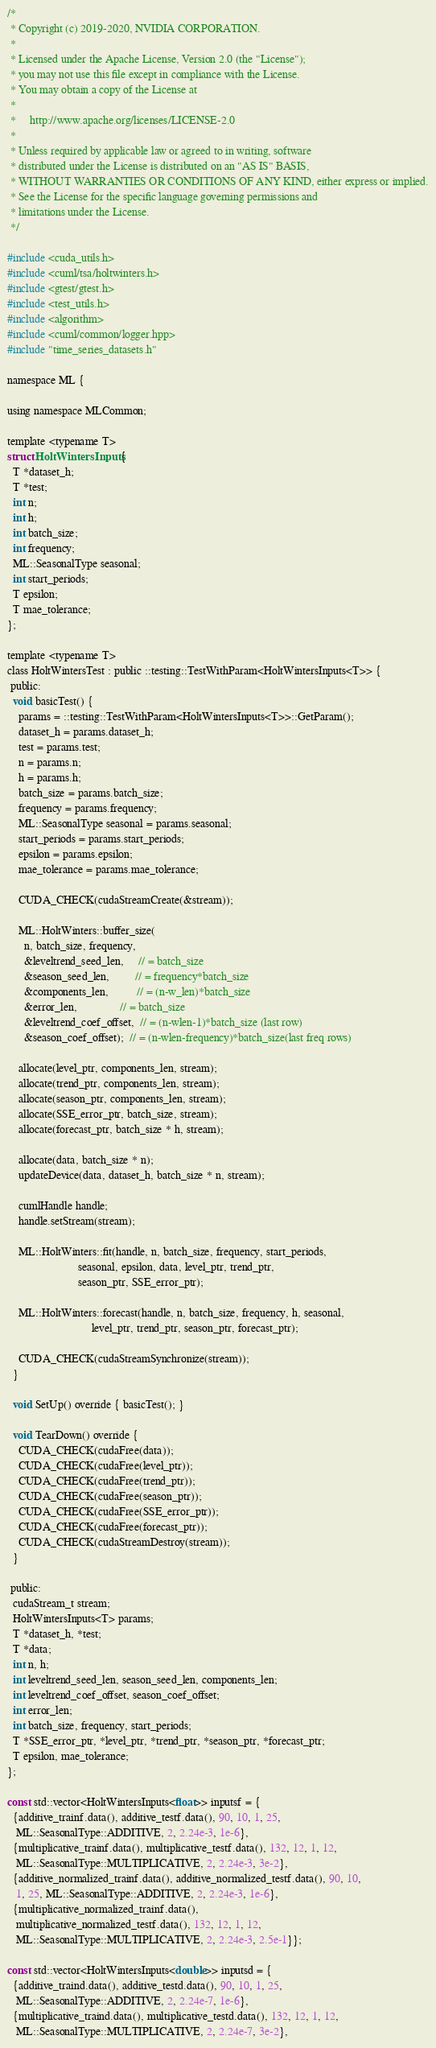<code> <loc_0><loc_0><loc_500><loc_500><_Cuda_>/*
 * Copyright (c) 2019-2020, NVIDIA CORPORATION.
 *
 * Licensed under the Apache License, Version 2.0 (the "License");
 * you may not use this file except in compliance with the License.
 * You may obtain a copy of the License at
 *
 *     http://www.apache.org/licenses/LICENSE-2.0
 *
 * Unless required by applicable law or agreed to in writing, software
 * distributed under the License is distributed on an "AS IS" BASIS,
 * WITHOUT WARRANTIES OR CONDITIONS OF ANY KIND, either express or implied.
 * See the License for the specific language governing permissions and
 * limitations under the License.
 */

#include <cuda_utils.h>
#include <cuml/tsa/holtwinters.h>
#include <gtest/gtest.h>
#include <test_utils.h>
#include <algorithm>
#include <cuml/common/logger.hpp>
#include "time_series_datasets.h"

namespace ML {

using namespace MLCommon;

template <typename T>
struct HoltWintersInputs {
  T *dataset_h;
  T *test;
  int n;
  int h;
  int batch_size;
  int frequency;
  ML::SeasonalType seasonal;
  int start_periods;
  T epsilon;
  T mae_tolerance;
};

template <typename T>
class HoltWintersTest : public ::testing::TestWithParam<HoltWintersInputs<T>> {
 public:
  void basicTest() {
    params = ::testing::TestWithParam<HoltWintersInputs<T>>::GetParam();
    dataset_h = params.dataset_h;
    test = params.test;
    n = params.n;
    h = params.h;
    batch_size = params.batch_size;
    frequency = params.frequency;
    ML::SeasonalType seasonal = params.seasonal;
    start_periods = params.start_periods;
    epsilon = params.epsilon;
    mae_tolerance = params.mae_tolerance;

    CUDA_CHECK(cudaStreamCreate(&stream));

    ML::HoltWinters::buffer_size(
      n, batch_size, frequency,
      &leveltrend_seed_len,     // = batch_size
      &season_seed_len,         // = frequency*batch_size
      &components_len,          // = (n-w_len)*batch_size
      &error_len,               // = batch_size
      &leveltrend_coef_offset,  // = (n-wlen-1)*batch_size (last row)
      &season_coef_offset);  // = (n-wlen-frequency)*batch_size(last freq rows)

    allocate(level_ptr, components_len, stream);
    allocate(trend_ptr, components_len, stream);
    allocate(season_ptr, components_len, stream);
    allocate(SSE_error_ptr, batch_size, stream);
    allocate(forecast_ptr, batch_size * h, stream);

    allocate(data, batch_size * n);
    updateDevice(data, dataset_h, batch_size * n, stream);

    cumlHandle handle;
    handle.setStream(stream);

    ML::HoltWinters::fit(handle, n, batch_size, frequency, start_periods,
                         seasonal, epsilon, data, level_ptr, trend_ptr,
                         season_ptr, SSE_error_ptr);

    ML::HoltWinters::forecast(handle, n, batch_size, frequency, h, seasonal,
                              level_ptr, trend_ptr, season_ptr, forecast_ptr);

    CUDA_CHECK(cudaStreamSynchronize(stream));
  }

  void SetUp() override { basicTest(); }

  void TearDown() override {
    CUDA_CHECK(cudaFree(data));
    CUDA_CHECK(cudaFree(level_ptr));
    CUDA_CHECK(cudaFree(trend_ptr));
    CUDA_CHECK(cudaFree(season_ptr));
    CUDA_CHECK(cudaFree(SSE_error_ptr));
    CUDA_CHECK(cudaFree(forecast_ptr));
    CUDA_CHECK(cudaStreamDestroy(stream));
  }

 public:
  cudaStream_t stream;
  HoltWintersInputs<T> params;
  T *dataset_h, *test;
  T *data;
  int n, h;
  int leveltrend_seed_len, season_seed_len, components_len;
  int leveltrend_coef_offset, season_coef_offset;
  int error_len;
  int batch_size, frequency, start_periods;
  T *SSE_error_ptr, *level_ptr, *trend_ptr, *season_ptr, *forecast_ptr;
  T epsilon, mae_tolerance;
};

const std::vector<HoltWintersInputs<float>> inputsf = {
  {additive_trainf.data(), additive_testf.data(), 90, 10, 1, 25,
   ML::SeasonalType::ADDITIVE, 2, 2.24e-3, 1e-6},
  {multiplicative_trainf.data(), multiplicative_testf.data(), 132, 12, 1, 12,
   ML::SeasonalType::MULTIPLICATIVE, 2, 2.24e-3, 3e-2},
  {additive_normalized_trainf.data(), additive_normalized_testf.data(), 90, 10,
   1, 25, ML::SeasonalType::ADDITIVE, 2, 2.24e-3, 1e-6},
  {multiplicative_normalized_trainf.data(),
   multiplicative_normalized_testf.data(), 132, 12, 1, 12,
   ML::SeasonalType::MULTIPLICATIVE, 2, 2.24e-3, 2.5e-1}};

const std::vector<HoltWintersInputs<double>> inputsd = {
  {additive_traind.data(), additive_testd.data(), 90, 10, 1, 25,
   ML::SeasonalType::ADDITIVE, 2, 2.24e-7, 1e-6},
  {multiplicative_traind.data(), multiplicative_testd.data(), 132, 12, 1, 12,
   ML::SeasonalType::MULTIPLICATIVE, 2, 2.24e-7, 3e-2},</code> 